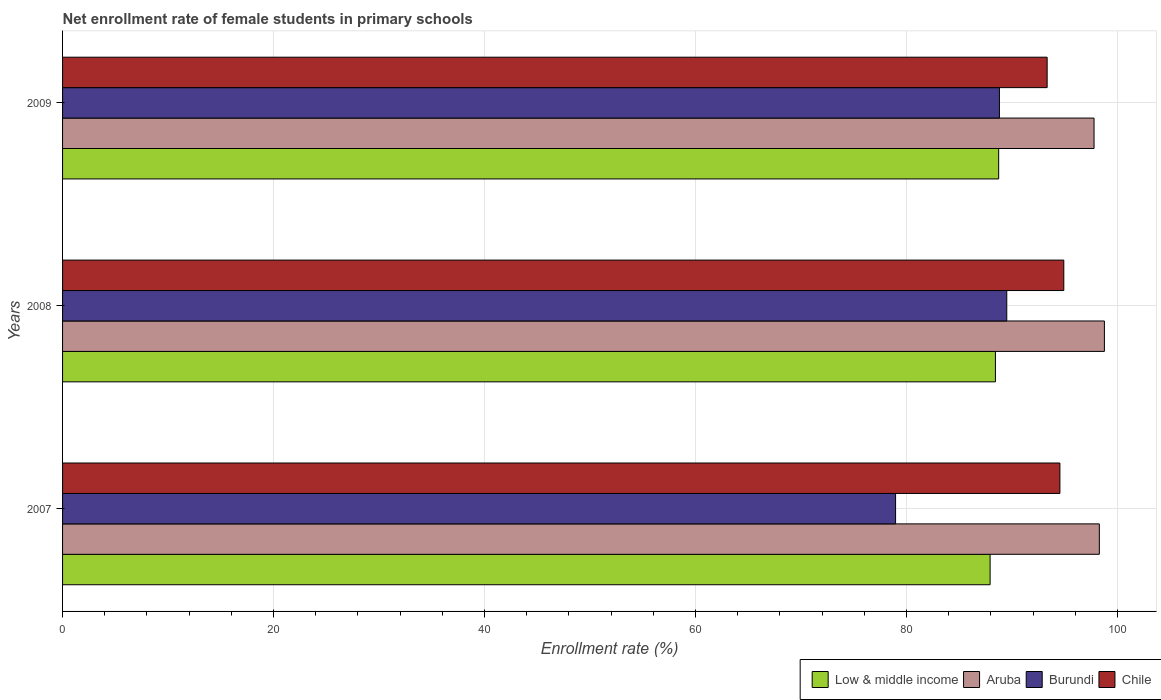How many different coloured bars are there?
Your response must be concise. 4. Are the number of bars per tick equal to the number of legend labels?
Provide a short and direct response. Yes. Are the number of bars on each tick of the Y-axis equal?
Provide a succinct answer. Yes. What is the net enrollment rate of female students in primary schools in Burundi in 2007?
Make the answer very short. 78.96. Across all years, what is the maximum net enrollment rate of female students in primary schools in Chile?
Provide a succinct answer. 94.91. Across all years, what is the minimum net enrollment rate of female students in primary schools in Chile?
Provide a short and direct response. 93.33. In which year was the net enrollment rate of female students in primary schools in Aruba maximum?
Ensure brevity in your answer.  2008. In which year was the net enrollment rate of female students in primary schools in Low & middle income minimum?
Make the answer very short. 2007. What is the total net enrollment rate of female students in primary schools in Burundi in the graph?
Make the answer very short. 257.27. What is the difference between the net enrollment rate of female students in primary schools in Aruba in 2007 and that in 2009?
Provide a short and direct response. 0.5. What is the difference between the net enrollment rate of female students in primary schools in Chile in 2009 and the net enrollment rate of female students in primary schools in Aruba in 2008?
Your answer should be compact. -5.43. What is the average net enrollment rate of female students in primary schools in Chile per year?
Offer a very short reply. 94.26. In the year 2009, what is the difference between the net enrollment rate of female students in primary schools in Aruba and net enrollment rate of female students in primary schools in Chile?
Your response must be concise. 4.45. What is the ratio of the net enrollment rate of female students in primary schools in Chile in 2007 to that in 2009?
Your answer should be compact. 1.01. Is the net enrollment rate of female students in primary schools in Aruba in 2008 less than that in 2009?
Provide a succinct answer. No. What is the difference between the highest and the second highest net enrollment rate of female students in primary schools in Low & middle income?
Provide a short and direct response. 0.31. What is the difference between the highest and the lowest net enrollment rate of female students in primary schools in Low & middle income?
Ensure brevity in your answer.  0.81. In how many years, is the net enrollment rate of female students in primary schools in Aruba greater than the average net enrollment rate of female students in primary schools in Aruba taken over all years?
Provide a succinct answer. 2. What does the 4th bar from the top in 2008 represents?
Your answer should be very brief. Low & middle income. Is it the case that in every year, the sum of the net enrollment rate of female students in primary schools in Aruba and net enrollment rate of female students in primary schools in Low & middle income is greater than the net enrollment rate of female students in primary schools in Chile?
Your answer should be very brief. Yes. How many bars are there?
Offer a terse response. 12. What is the difference between two consecutive major ticks on the X-axis?
Provide a succinct answer. 20. Does the graph contain grids?
Provide a short and direct response. Yes. Where does the legend appear in the graph?
Provide a succinct answer. Bottom right. How many legend labels are there?
Provide a succinct answer. 4. How are the legend labels stacked?
Your response must be concise. Horizontal. What is the title of the graph?
Your answer should be compact. Net enrollment rate of female students in primary schools. What is the label or title of the X-axis?
Your answer should be compact. Enrollment rate (%). What is the label or title of the Y-axis?
Provide a short and direct response. Years. What is the Enrollment rate (%) in Low & middle income in 2007?
Offer a very short reply. 87.92. What is the Enrollment rate (%) in Aruba in 2007?
Your response must be concise. 98.28. What is the Enrollment rate (%) in Burundi in 2007?
Provide a short and direct response. 78.96. What is the Enrollment rate (%) in Chile in 2007?
Ensure brevity in your answer.  94.54. What is the Enrollment rate (%) of Low & middle income in 2008?
Your response must be concise. 88.43. What is the Enrollment rate (%) in Aruba in 2008?
Give a very brief answer. 98.76. What is the Enrollment rate (%) of Burundi in 2008?
Your response must be concise. 89.5. What is the Enrollment rate (%) of Chile in 2008?
Provide a short and direct response. 94.91. What is the Enrollment rate (%) in Low & middle income in 2009?
Your answer should be very brief. 88.74. What is the Enrollment rate (%) of Aruba in 2009?
Your answer should be compact. 97.78. What is the Enrollment rate (%) of Burundi in 2009?
Ensure brevity in your answer.  88.81. What is the Enrollment rate (%) in Chile in 2009?
Offer a very short reply. 93.33. Across all years, what is the maximum Enrollment rate (%) of Low & middle income?
Keep it short and to the point. 88.74. Across all years, what is the maximum Enrollment rate (%) in Aruba?
Offer a very short reply. 98.76. Across all years, what is the maximum Enrollment rate (%) in Burundi?
Your response must be concise. 89.5. Across all years, what is the maximum Enrollment rate (%) of Chile?
Provide a succinct answer. 94.91. Across all years, what is the minimum Enrollment rate (%) of Low & middle income?
Your response must be concise. 87.92. Across all years, what is the minimum Enrollment rate (%) in Aruba?
Provide a short and direct response. 97.78. Across all years, what is the minimum Enrollment rate (%) in Burundi?
Keep it short and to the point. 78.96. Across all years, what is the minimum Enrollment rate (%) in Chile?
Make the answer very short. 93.33. What is the total Enrollment rate (%) of Low & middle income in the graph?
Your answer should be compact. 265.09. What is the total Enrollment rate (%) in Aruba in the graph?
Provide a short and direct response. 294.81. What is the total Enrollment rate (%) in Burundi in the graph?
Ensure brevity in your answer.  257.27. What is the total Enrollment rate (%) of Chile in the graph?
Your answer should be very brief. 282.78. What is the difference between the Enrollment rate (%) of Low & middle income in 2007 and that in 2008?
Give a very brief answer. -0.5. What is the difference between the Enrollment rate (%) of Aruba in 2007 and that in 2008?
Offer a terse response. -0.48. What is the difference between the Enrollment rate (%) in Burundi in 2007 and that in 2008?
Your answer should be very brief. -10.54. What is the difference between the Enrollment rate (%) of Chile in 2007 and that in 2008?
Your answer should be compact. -0.37. What is the difference between the Enrollment rate (%) of Low & middle income in 2007 and that in 2009?
Offer a very short reply. -0.81. What is the difference between the Enrollment rate (%) in Aruba in 2007 and that in 2009?
Keep it short and to the point. 0.5. What is the difference between the Enrollment rate (%) of Burundi in 2007 and that in 2009?
Keep it short and to the point. -9.84. What is the difference between the Enrollment rate (%) in Chile in 2007 and that in 2009?
Provide a short and direct response. 1.21. What is the difference between the Enrollment rate (%) of Low & middle income in 2008 and that in 2009?
Ensure brevity in your answer.  -0.31. What is the difference between the Enrollment rate (%) in Aruba in 2008 and that in 2009?
Your answer should be compact. 0.98. What is the difference between the Enrollment rate (%) in Burundi in 2008 and that in 2009?
Your answer should be compact. 0.7. What is the difference between the Enrollment rate (%) of Chile in 2008 and that in 2009?
Give a very brief answer. 1.58. What is the difference between the Enrollment rate (%) of Low & middle income in 2007 and the Enrollment rate (%) of Aruba in 2008?
Your answer should be compact. -10.83. What is the difference between the Enrollment rate (%) in Low & middle income in 2007 and the Enrollment rate (%) in Burundi in 2008?
Give a very brief answer. -1.58. What is the difference between the Enrollment rate (%) of Low & middle income in 2007 and the Enrollment rate (%) of Chile in 2008?
Give a very brief answer. -6.99. What is the difference between the Enrollment rate (%) of Aruba in 2007 and the Enrollment rate (%) of Burundi in 2008?
Keep it short and to the point. 8.78. What is the difference between the Enrollment rate (%) in Aruba in 2007 and the Enrollment rate (%) in Chile in 2008?
Give a very brief answer. 3.37. What is the difference between the Enrollment rate (%) in Burundi in 2007 and the Enrollment rate (%) in Chile in 2008?
Make the answer very short. -15.95. What is the difference between the Enrollment rate (%) of Low & middle income in 2007 and the Enrollment rate (%) of Aruba in 2009?
Offer a very short reply. -9.85. What is the difference between the Enrollment rate (%) of Low & middle income in 2007 and the Enrollment rate (%) of Burundi in 2009?
Make the answer very short. -0.88. What is the difference between the Enrollment rate (%) of Low & middle income in 2007 and the Enrollment rate (%) of Chile in 2009?
Your response must be concise. -5.41. What is the difference between the Enrollment rate (%) in Aruba in 2007 and the Enrollment rate (%) in Burundi in 2009?
Offer a terse response. 9.47. What is the difference between the Enrollment rate (%) in Aruba in 2007 and the Enrollment rate (%) in Chile in 2009?
Offer a terse response. 4.95. What is the difference between the Enrollment rate (%) in Burundi in 2007 and the Enrollment rate (%) in Chile in 2009?
Your response must be concise. -14.37. What is the difference between the Enrollment rate (%) in Low & middle income in 2008 and the Enrollment rate (%) in Aruba in 2009?
Provide a short and direct response. -9.35. What is the difference between the Enrollment rate (%) of Low & middle income in 2008 and the Enrollment rate (%) of Burundi in 2009?
Keep it short and to the point. -0.38. What is the difference between the Enrollment rate (%) in Low & middle income in 2008 and the Enrollment rate (%) in Chile in 2009?
Give a very brief answer. -4.9. What is the difference between the Enrollment rate (%) of Aruba in 2008 and the Enrollment rate (%) of Burundi in 2009?
Make the answer very short. 9.95. What is the difference between the Enrollment rate (%) in Aruba in 2008 and the Enrollment rate (%) in Chile in 2009?
Give a very brief answer. 5.43. What is the difference between the Enrollment rate (%) of Burundi in 2008 and the Enrollment rate (%) of Chile in 2009?
Make the answer very short. -3.83. What is the average Enrollment rate (%) in Low & middle income per year?
Ensure brevity in your answer.  88.36. What is the average Enrollment rate (%) in Aruba per year?
Your answer should be very brief. 98.27. What is the average Enrollment rate (%) in Burundi per year?
Provide a succinct answer. 85.76. What is the average Enrollment rate (%) of Chile per year?
Offer a very short reply. 94.26. In the year 2007, what is the difference between the Enrollment rate (%) of Low & middle income and Enrollment rate (%) of Aruba?
Keep it short and to the point. -10.36. In the year 2007, what is the difference between the Enrollment rate (%) in Low & middle income and Enrollment rate (%) in Burundi?
Give a very brief answer. 8.96. In the year 2007, what is the difference between the Enrollment rate (%) in Low & middle income and Enrollment rate (%) in Chile?
Provide a succinct answer. -6.62. In the year 2007, what is the difference between the Enrollment rate (%) in Aruba and Enrollment rate (%) in Burundi?
Offer a very short reply. 19.32. In the year 2007, what is the difference between the Enrollment rate (%) of Aruba and Enrollment rate (%) of Chile?
Provide a succinct answer. 3.74. In the year 2007, what is the difference between the Enrollment rate (%) in Burundi and Enrollment rate (%) in Chile?
Provide a short and direct response. -15.58. In the year 2008, what is the difference between the Enrollment rate (%) of Low & middle income and Enrollment rate (%) of Aruba?
Make the answer very short. -10.33. In the year 2008, what is the difference between the Enrollment rate (%) in Low & middle income and Enrollment rate (%) in Burundi?
Give a very brief answer. -1.07. In the year 2008, what is the difference between the Enrollment rate (%) of Low & middle income and Enrollment rate (%) of Chile?
Provide a succinct answer. -6.48. In the year 2008, what is the difference between the Enrollment rate (%) of Aruba and Enrollment rate (%) of Burundi?
Give a very brief answer. 9.25. In the year 2008, what is the difference between the Enrollment rate (%) of Aruba and Enrollment rate (%) of Chile?
Offer a very short reply. 3.85. In the year 2008, what is the difference between the Enrollment rate (%) in Burundi and Enrollment rate (%) in Chile?
Ensure brevity in your answer.  -5.41. In the year 2009, what is the difference between the Enrollment rate (%) of Low & middle income and Enrollment rate (%) of Aruba?
Your answer should be compact. -9.04. In the year 2009, what is the difference between the Enrollment rate (%) in Low & middle income and Enrollment rate (%) in Burundi?
Provide a succinct answer. -0.07. In the year 2009, what is the difference between the Enrollment rate (%) of Low & middle income and Enrollment rate (%) of Chile?
Your answer should be very brief. -4.59. In the year 2009, what is the difference between the Enrollment rate (%) of Aruba and Enrollment rate (%) of Burundi?
Make the answer very short. 8.97. In the year 2009, what is the difference between the Enrollment rate (%) in Aruba and Enrollment rate (%) in Chile?
Keep it short and to the point. 4.45. In the year 2009, what is the difference between the Enrollment rate (%) of Burundi and Enrollment rate (%) of Chile?
Make the answer very short. -4.52. What is the ratio of the Enrollment rate (%) in Aruba in 2007 to that in 2008?
Your response must be concise. 1. What is the ratio of the Enrollment rate (%) in Burundi in 2007 to that in 2008?
Your answer should be very brief. 0.88. What is the ratio of the Enrollment rate (%) of Chile in 2007 to that in 2008?
Your response must be concise. 1. What is the ratio of the Enrollment rate (%) in Low & middle income in 2007 to that in 2009?
Your answer should be compact. 0.99. What is the ratio of the Enrollment rate (%) of Burundi in 2007 to that in 2009?
Your answer should be compact. 0.89. What is the ratio of the Enrollment rate (%) in Chile in 2007 to that in 2009?
Keep it short and to the point. 1.01. What is the ratio of the Enrollment rate (%) of Aruba in 2008 to that in 2009?
Offer a very short reply. 1.01. What is the ratio of the Enrollment rate (%) of Chile in 2008 to that in 2009?
Your answer should be very brief. 1.02. What is the difference between the highest and the second highest Enrollment rate (%) of Low & middle income?
Your answer should be compact. 0.31. What is the difference between the highest and the second highest Enrollment rate (%) in Aruba?
Make the answer very short. 0.48. What is the difference between the highest and the second highest Enrollment rate (%) of Burundi?
Keep it short and to the point. 0.7. What is the difference between the highest and the second highest Enrollment rate (%) in Chile?
Give a very brief answer. 0.37. What is the difference between the highest and the lowest Enrollment rate (%) in Low & middle income?
Your answer should be very brief. 0.81. What is the difference between the highest and the lowest Enrollment rate (%) of Aruba?
Ensure brevity in your answer.  0.98. What is the difference between the highest and the lowest Enrollment rate (%) of Burundi?
Give a very brief answer. 10.54. What is the difference between the highest and the lowest Enrollment rate (%) of Chile?
Your answer should be compact. 1.58. 